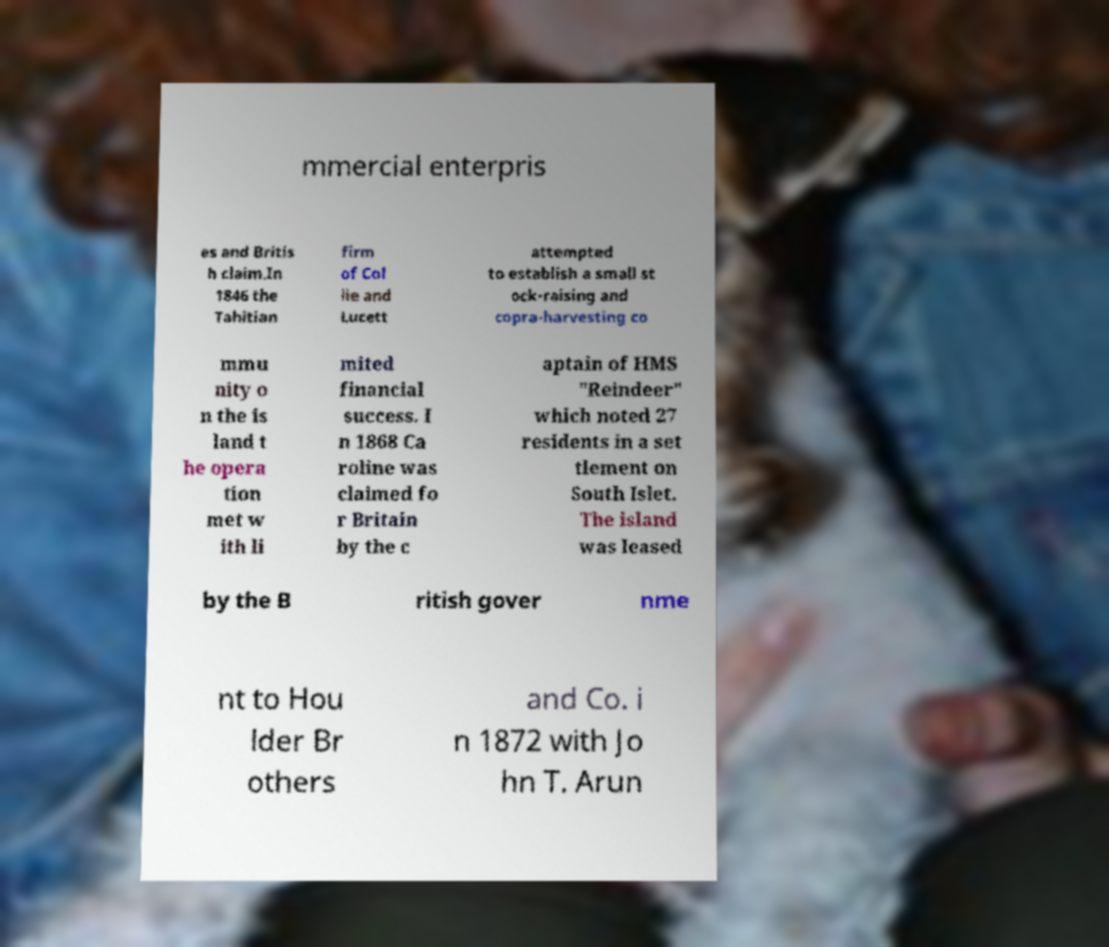Can you accurately transcribe the text from the provided image for me? mmercial enterpris es and Britis h claim.In 1846 the Tahitian firm of Col lie and Lucett attempted to establish a small st ock-raising and copra-harvesting co mmu nity o n the is land t he opera tion met w ith li mited financial success. I n 1868 Ca roline was claimed fo r Britain by the c aptain of HMS "Reindeer" which noted 27 residents in a set tlement on South Islet. The island was leased by the B ritish gover nme nt to Hou lder Br others and Co. i n 1872 with Jo hn T. Arun 